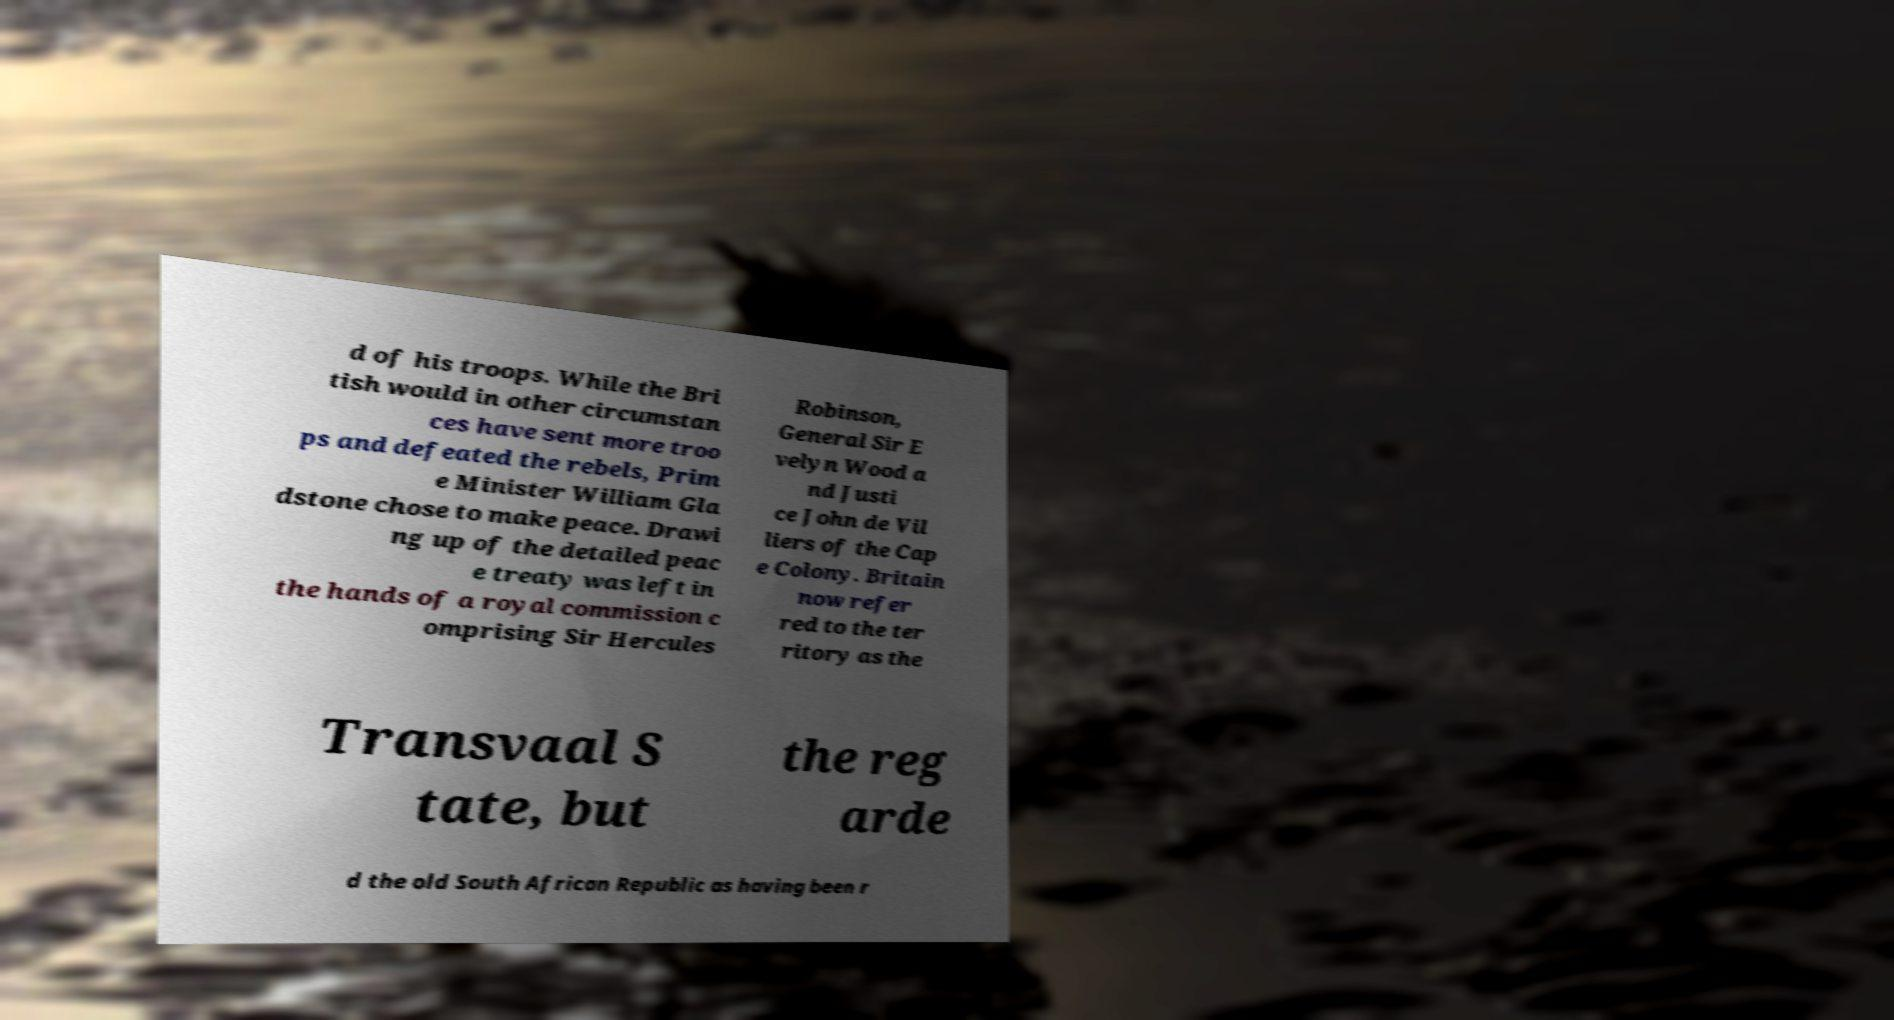What messages or text are displayed in this image? I need them in a readable, typed format. d of his troops. While the Bri tish would in other circumstan ces have sent more troo ps and defeated the rebels, Prim e Minister William Gla dstone chose to make peace. Drawi ng up of the detailed peac e treaty was left in the hands of a royal commission c omprising Sir Hercules Robinson, General Sir E velyn Wood a nd Justi ce John de Vil liers of the Cap e Colony. Britain now refer red to the ter ritory as the Transvaal S tate, but the reg arde d the old South African Republic as having been r 